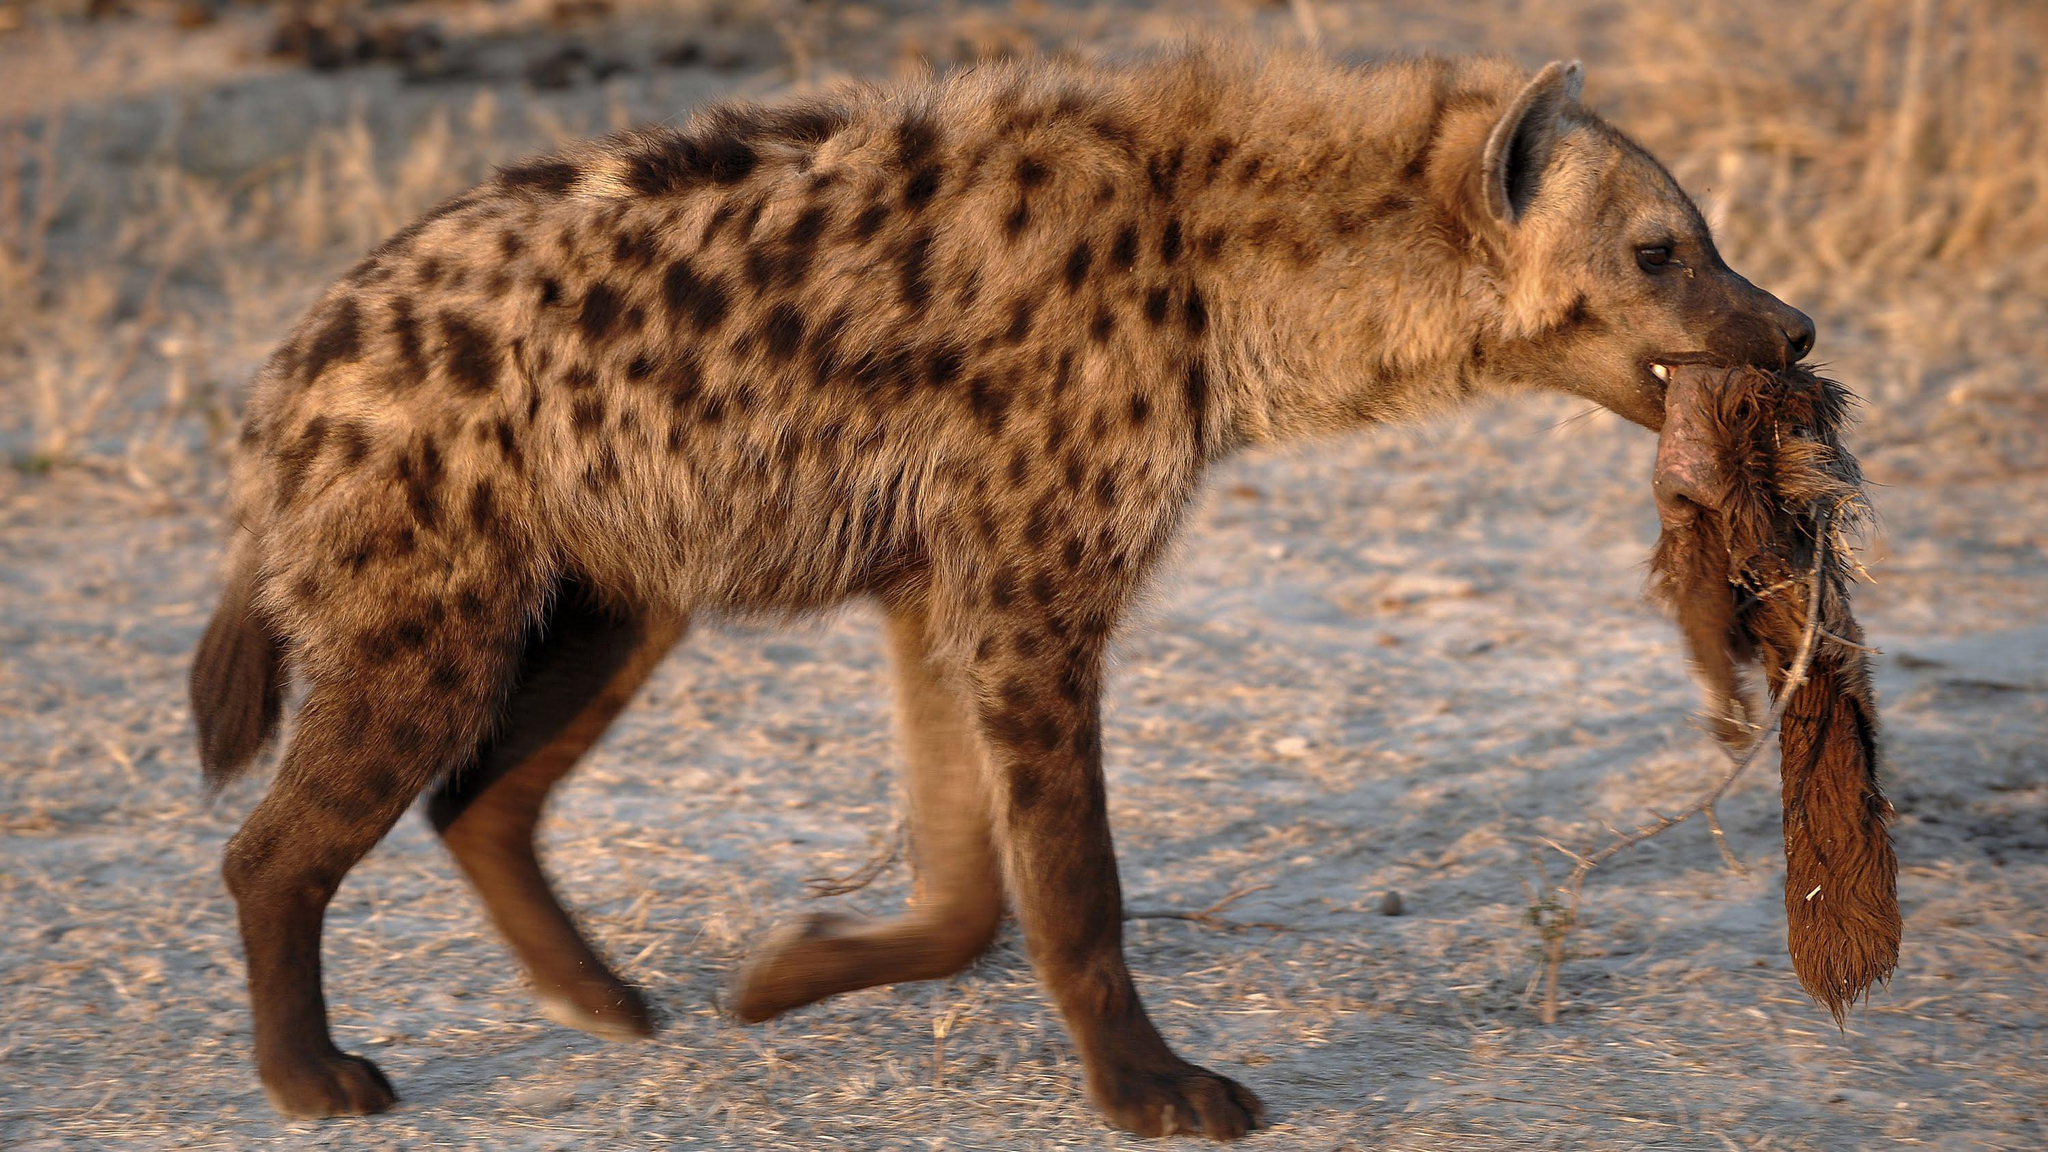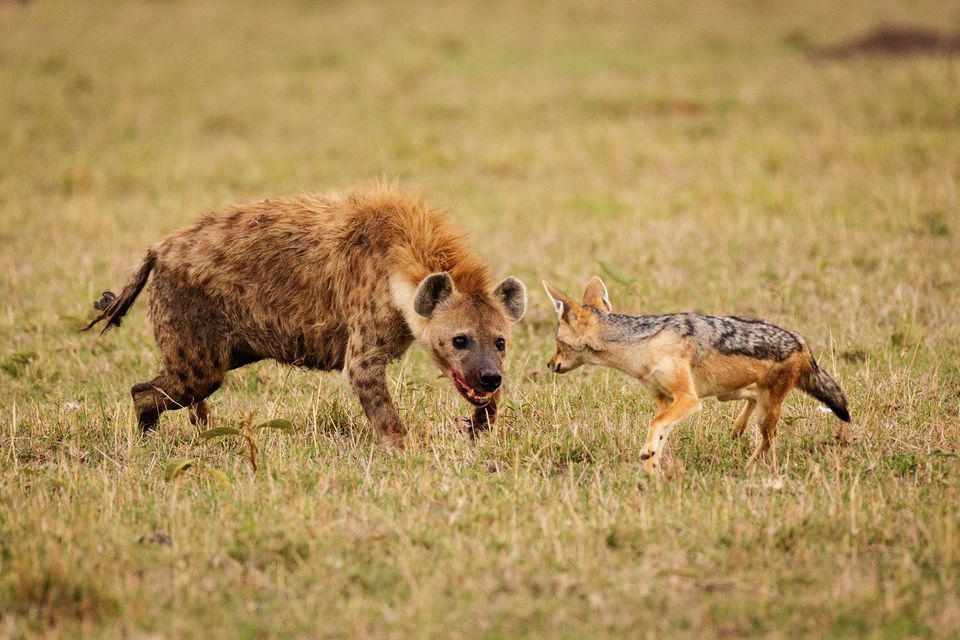The first image is the image on the left, the second image is the image on the right. Given the left and right images, does the statement "An image shows a hyena facing a smaller fox-like animal." hold true? Answer yes or no. Yes. The first image is the image on the left, the second image is the image on the right. For the images shown, is this caption "A predator and its prey are facing off in the image on the right." true? Answer yes or no. Yes. 